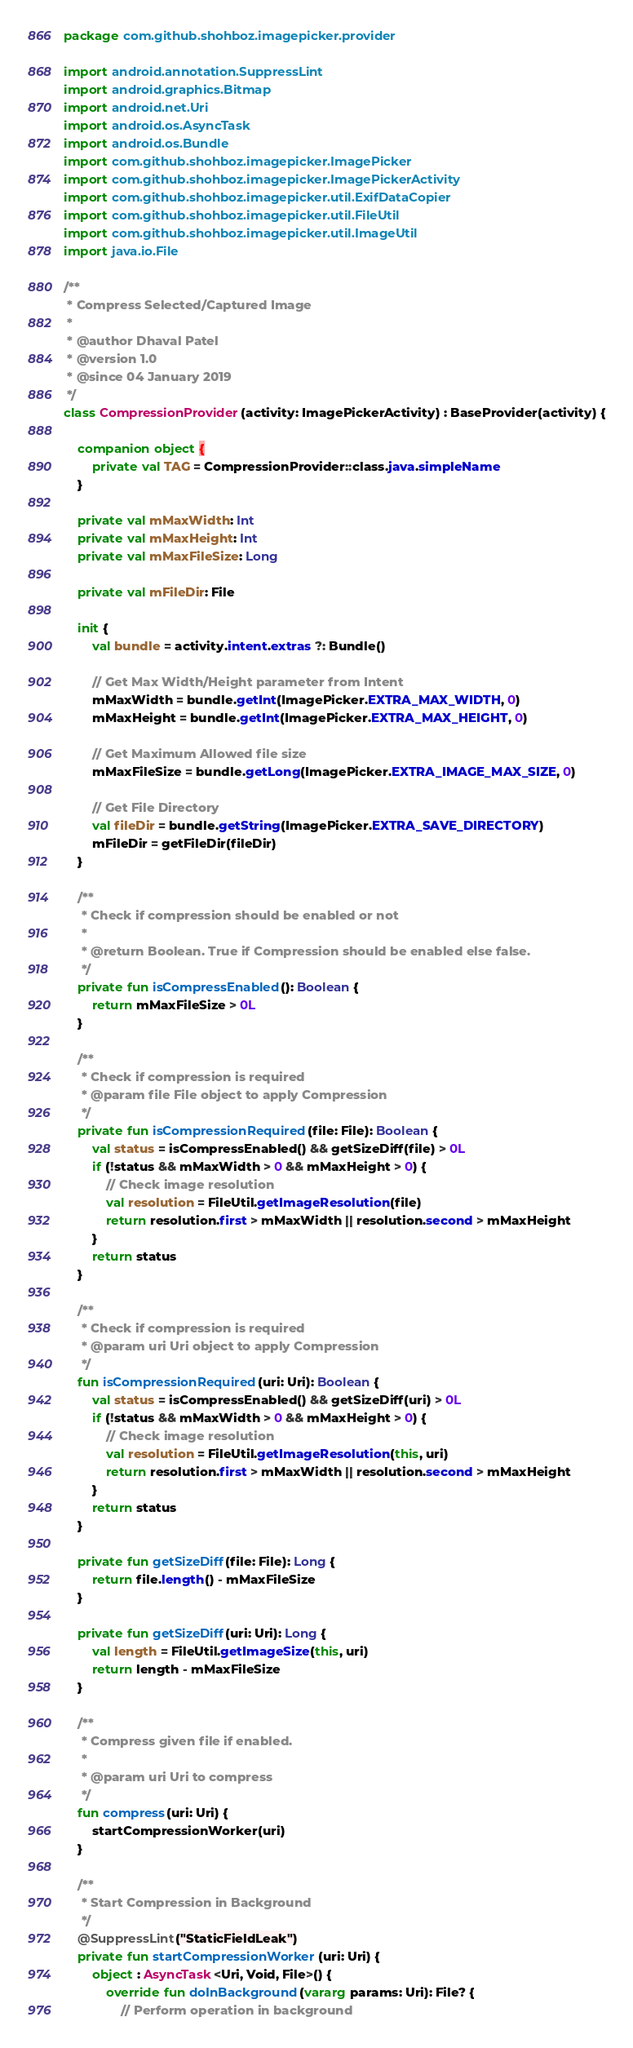Convert code to text. <code><loc_0><loc_0><loc_500><loc_500><_Kotlin_>package com.github.shohboz.imagepicker.provider

import android.annotation.SuppressLint
import android.graphics.Bitmap
import android.net.Uri
import android.os.AsyncTask
import android.os.Bundle
import com.github.shohboz.imagepicker.ImagePicker
import com.github.shohboz.imagepicker.ImagePickerActivity
import com.github.shohboz.imagepicker.util.ExifDataCopier
import com.github.shohboz.imagepicker.util.FileUtil
import com.github.shohboz.imagepicker.util.ImageUtil
import java.io.File

/**
 * Compress Selected/Captured Image
 *
 * @author Dhaval Patel
 * @version 1.0
 * @since 04 January 2019
 */
class CompressionProvider(activity: ImagePickerActivity) : BaseProvider(activity) {

    companion object {
        private val TAG = CompressionProvider::class.java.simpleName
    }

    private val mMaxWidth: Int
    private val mMaxHeight: Int
    private val mMaxFileSize: Long

    private val mFileDir: File

    init {
        val bundle = activity.intent.extras ?: Bundle()

        // Get Max Width/Height parameter from Intent
        mMaxWidth = bundle.getInt(ImagePicker.EXTRA_MAX_WIDTH, 0)
        mMaxHeight = bundle.getInt(ImagePicker.EXTRA_MAX_HEIGHT, 0)

        // Get Maximum Allowed file size
        mMaxFileSize = bundle.getLong(ImagePicker.EXTRA_IMAGE_MAX_SIZE, 0)

        // Get File Directory
        val fileDir = bundle.getString(ImagePicker.EXTRA_SAVE_DIRECTORY)
        mFileDir = getFileDir(fileDir)
    }

    /**
     * Check if compression should be enabled or not
     *
     * @return Boolean. True if Compression should be enabled else false.
     */
    private fun isCompressEnabled(): Boolean {
        return mMaxFileSize > 0L
    }

    /**
     * Check if compression is required
     * @param file File object to apply Compression
     */
    private fun isCompressionRequired(file: File): Boolean {
        val status = isCompressEnabled() && getSizeDiff(file) > 0L
        if (!status && mMaxWidth > 0 && mMaxHeight > 0) {
            // Check image resolution
            val resolution = FileUtil.getImageResolution(file)
            return resolution.first > mMaxWidth || resolution.second > mMaxHeight
        }
        return status
    }

    /**
     * Check if compression is required
     * @param uri Uri object to apply Compression
     */
    fun isCompressionRequired(uri: Uri): Boolean {
        val status = isCompressEnabled() && getSizeDiff(uri) > 0L
        if (!status && mMaxWidth > 0 && mMaxHeight > 0) {
            // Check image resolution
            val resolution = FileUtil.getImageResolution(this, uri)
            return resolution.first > mMaxWidth || resolution.second > mMaxHeight
        }
        return status
    }

    private fun getSizeDiff(file: File): Long {
        return file.length() - mMaxFileSize
    }

    private fun getSizeDiff(uri: Uri): Long {
        val length = FileUtil.getImageSize(this, uri)
        return length - mMaxFileSize
    }

    /**
     * Compress given file if enabled.
     *
     * @param uri Uri to compress
     */
    fun compress(uri: Uri) {
        startCompressionWorker(uri)
    }

    /**
     * Start Compression in Background
     */
    @SuppressLint("StaticFieldLeak")
    private fun startCompressionWorker(uri: Uri) {
        object : AsyncTask<Uri, Void, File>() {
            override fun doInBackground(vararg params: Uri): File? {
                // Perform operation in background</code> 